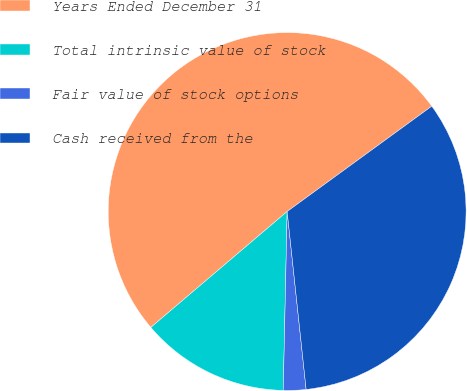Convert chart. <chart><loc_0><loc_0><loc_500><loc_500><pie_chart><fcel>Years Ended December 31<fcel>Total intrinsic value of stock<fcel>Fair value of stock options<fcel>Cash received from the<nl><fcel>51.2%<fcel>13.44%<fcel>2.04%<fcel>33.33%<nl></chart> 